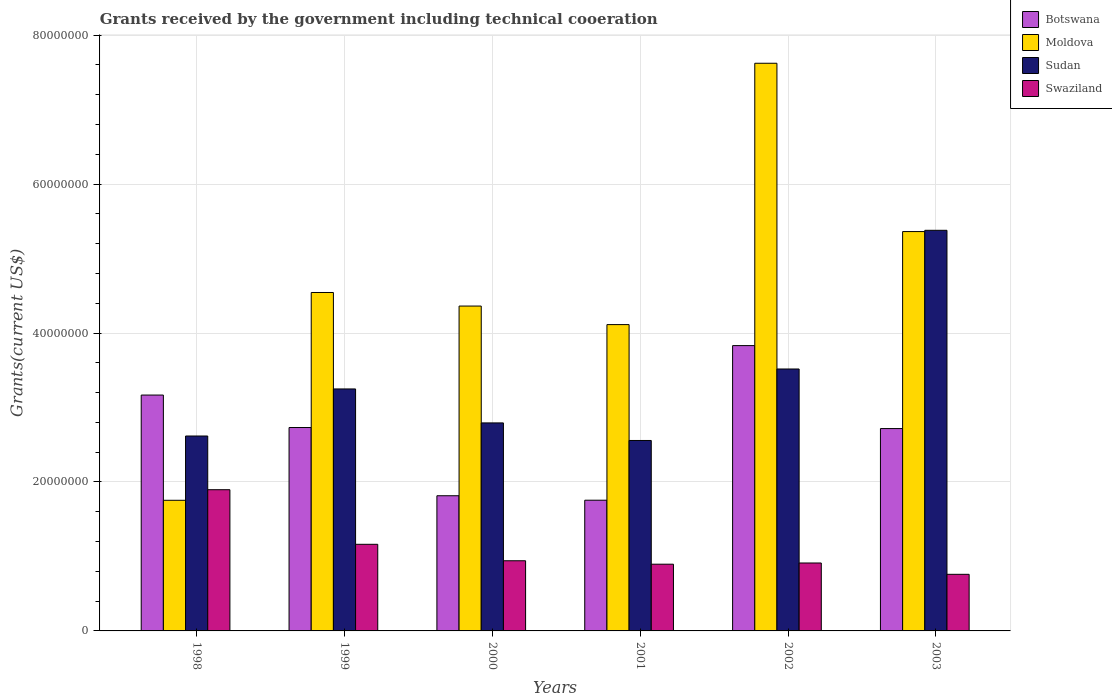How many groups of bars are there?
Offer a very short reply. 6. How many bars are there on the 5th tick from the left?
Give a very brief answer. 4. How many bars are there on the 3rd tick from the right?
Offer a very short reply. 4. What is the label of the 6th group of bars from the left?
Offer a very short reply. 2003. In how many cases, is the number of bars for a given year not equal to the number of legend labels?
Ensure brevity in your answer.  0. What is the total grants received by the government in Swaziland in 2003?
Make the answer very short. 7.60e+06. Across all years, what is the maximum total grants received by the government in Botswana?
Offer a very short reply. 3.83e+07. Across all years, what is the minimum total grants received by the government in Swaziland?
Offer a very short reply. 7.60e+06. In which year was the total grants received by the government in Botswana minimum?
Offer a very short reply. 2001. What is the total total grants received by the government in Botswana in the graph?
Your response must be concise. 1.60e+08. What is the difference between the total grants received by the government in Botswana in 1998 and that in 2000?
Keep it short and to the point. 1.35e+07. What is the difference between the total grants received by the government in Sudan in 2002 and the total grants received by the government in Moldova in 1999?
Your response must be concise. -1.03e+07. What is the average total grants received by the government in Botswana per year?
Your response must be concise. 2.67e+07. In the year 2000, what is the difference between the total grants received by the government in Moldova and total grants received by the government in Botswana?
Provide a short and direct response. 2.55e+07. In how many years, is the total grants received by the government in Moldova greater than 12000000 US$?
Provide a short and direct response. 6. What is the ratio of the total grants received by the government in Botswana in 1999 to that in 2001?
Keep it short and to the point. 1.56. Is the total grants received by the government in Botswana in 2000 less than that in 2001?
Give a very brief answer. No. What is the difference between the highest and the second highest total grants received by the government in Sudan?
Your answer should be compact. 1.86e+07. What is the difference between the highest and the lowest total grants received by the government in Sudan?
Ensure brevity in your answer.  2.82e+07. Is the sum of the total grants received by the government in Sudan in 2000 and 2003 greater than the maximum total grants received by the government in Moldova across all years?
Ensure brevity in your answer.  Yes. Is it the case that in every year, the sum of the total grants received by the government in Swaziland and total grants received by the government in Sudan is greater than the sum of total grants received by the government in Moldova and total grants received by the government in Botswana?
Provide a short and direct response. No. What does the 3rd bar from the left in 2003 represents?
Your answer should be compact. Sudan. What does the 3rd bar from the right in 2001 represents?
Give a very brief answer. Moldova. How many bars are there?
Provide a short and direct response. 24. What is the difference between two consecutive major ticks on the Y-axis?
Provide a succinct answer. 2.00e+07. Are the values on the major ticks of Y-axis written in scientific E-notation?
Provide a short and direct response. No. Does the graph contain any zero values?
Your answer should be compact. No. Does the graph contain grids?
Offer a terse response. Yes. Where does the legend appear in the graph?
Keep it short and to the point. Top right. What is the title of the graph?
Your answer should be very brief. Grants received by the government including technical cooeration. What is the label or title of the Y-axis?
Provide a short and direct response. Grants(current US$). What is the Grants(current US$) of Botswana in 1998?
Provide a short and direct response. 3.17e+07. What is the Grants(current US$) of Moldova in 1998?
Your answer should be very brief. 1.75e+07. What is the Grants(current US$) of Sudan in 1998?
Your answer should be very brief. 2.62e+07. What is the Grants(current US$) in Swaziland in 1998?
Give a very brief answer. 1.90e+07. What is the Grants(current US$) in Botswana in 1999?
Provide a succinct answer. 2.73e+07. What is the Grants(current US$) of Moldova in 1999?
Keep it short and to the point. 4.54e+07. What is the Grants(current US$) of Sudan in 1999?
Keep it short and to the point. 3.25e+07. What is the Grants(current US$) in Swaziland in 1999?
Provide a short and direct response. 1.16e+07. What is the Grants(current US$) of Botswana in 2000?
Keep it short and to the point. 1.82e+07. What is the Grants(current US$) in Moldova in 2000?
Ensure brevity in your answer.  4.36e+07. What is the Grants(current US$) of Sudan in 2000?
Keep it short and to the point. 2.79e+07. What is the Grants(current US$) of Swaziland in 2000?
Provide a succinct answer. 9.42e+06. What is the Grants(current US$) of Botswana in 2001?
Your answer should be very brief. 1.76e+07. What is the Grants(current US$) of Moldova in 2001?
Make the answer very short. 4.11e+07. What is the Grants(current US$) of Sudan in 2001?
Give a very brief answer. 2.56e+07. What is the Grants(current US$) of Swaziland in 2001?
Keep it short and to the point. 8.96e+06. What is the Grants(current US$) of Botswana in 2002?
Keep it short and to the point. 3.83e+07. What is the Grants(current US$) of Moldova in 2002?
Offer a very short reply. 7.62e+07. What is the Grants(current US$) of Sudan in 2002?
Offer a terse response. 3.52e+07. What is the Grants(current US$) in Swaziland in 2002?
Provide a short and direct response. 9.12e+06. What is the Grants(current US$) in Botswana in 2003?
Provide a short and direct response. 2.72e+07. What is the Grants(current US$) in Moldova in 2003?
Make the answer very short. 5.36e+07. What is the Grants(current US$) in Sudan in 2003?
Provide a short and direct response. 5.38e+07. What is the Grants(current US$) of Swaziland in 2003?
Provide a short and direct response. 7.60e+06. Across all years, what is the maximum Grants(current US$) of Botswana?
Provide a short and direct response. 3.83e+07. Across all years, what is the maximum Grants(current US$) in Moldova?
Ensure brevity in your answer.  7.62e+07. Across all years, what is the maximum Grants(current US$) in Sudan?
Offer a very short reply. 5.38e+07. Across all years, what is the maximum Grants(current US$) in Swaziland?
Provide a short and direct response. 1.90e+07. Across all years, what is the minimum Grants(current US$) in Botswana?
Ensure brevity in your answer.  1.76e+07. Across all years, what is the minimum Grants(current US$) in Moldova?
Your response must be concise. 1.75e+07. Across all years, what is the minimum Grants(current US$) in Sudan?
Provide a short and direct response. 2.56e+07. Across all years, what is the minimum Grants(current US$) of Swaziland?
Provide a succinct answer. 7.60e+06. What is the total Grants(current US$) in Botswana in the graph?
Offer a terse response. 1.60e+08. What is the total Grants(current US$) in Moldova in the graph?
Ensure brevity in your answer.  2.78e+08. What is the total Grants(current US$) in Sudan in the graph?
Ensure brevity in your answer.  2.01e+08. What is the total Grants(current US$) of Swaziland in the graph?
Keep it short and to the point. 6.57e+07. What is the difference between the Grants(current US$) of Botswana in 1998 and that in 1999?
Offer a terse response. 4.36e+06. What is the difference between the Grants(current US$) of Moldova in 1998 and that in 1999?
Offer a very short reply. -2.79e+07. What is the difference between the Grants(current US$) of Sudan in 1998 and that in 1999?
Your response must be concise. -6.32e+06. What is the difference between the Grants(current US$) of Swaziland in 1998 and that in 1999?
Offer a very short reply. 7.33e+06. What is the difference between the Grants(current US$) in Botswana in 1998 and that in 2000?
Provide a succinct answer. 1.35e+07. What is the difference between the Grants(current US$) of Moldova in 1998 and that in 2000?
Give a very brief answer. -2.61e+07. What is the difference between the Grants(current US$) in Sudan in 1998 and that in 2000?
Your answer should be very brief. -1.76e+06. What is the difference between the Grants(current US$) in Swaziland in 1998 and that in 2000?
Make the answer very short. 9.54e+06. What is the difference between the Grants(current US$) of Botswana in 1998 and that in 2001?
Keep it short and to the point. 1.41e+07. What is the difference between the Grants(current US$) in Moldova in 1998 and that in 2001?
Ensure brevity in your answer.  -2.36e+07. What is the difference between the Grants(current US$) of Sudan in 1998 and that in 2001?
Give a very brief answer. 6.00e+05. What is the difference between the Grants(current US$) in Swaziland in 1998 and that in 2001?
Your response must be concise. 1.00e+07. What is the difference between the Grants(current US$) of Botswana in 1998 and that in 2002?
Your response must be concise. -6.64e+06. What is the difference between the Grants(current US$) in Moldova in 1998 and that in 2002?
Offer a terse response. -5.87e+07. What is the difference between the Grants(current US$) in Sudan in 1998 and that in 2002?
Provide a succinct answer. -9.00e+06. What is the difference between the Grants(current US$) in Swaziland in 1998 and that in 2002?
Keep it short and to the point. 9.84e+06. What is the difference between the Grants(current US$) in Botswana in 1998 and that in 2003?
Keep it short and to the point. 4.50e+06. What is the difference between the Grants(current US$) of Moldova in 1998 and that in 2003?
Your answer should be very brief. -3.61e+07. What is the difference between the Grants(current US$) of Sudan in 1998 and that in 2003?
Offer a very short reply. -2.76e+07. What is the difference between the Grants(current US$) in Swaziland in 1998 and that in 2003?
Give a very brief answer. 1.14e+07. What is the difference between the Grants(current US$) in Botswana in 1999 and that in 2000?
Offer a very short reply. 9.16e+06. What is the difference between the Grants(current US$) of Moldova in 1999 and that in 2000?
Your response must be concise. 1.82e+06. What is the difference between the Grants(current US$) of Sudan in 1999 and that in 2000?
Your answer should be very brief. 4.56e+06. What is the difference between the Grants(current US$) of Swaziland in 1999 and that in 2000?
Ensure brevity in your answer.  2.21e+06. What is the difference between the Grants(current US$) in Botswana in 1999 and that in 2001?
Your response must be concise. 9.76e+06. What is the difference between the Grants(current US$) in Moldova in 1999 and that in 2001?
Offer a terse response. 4.31e+06. What is the difference between the Grants(current US$) of Sudan in 1999 and that in 2001?
Your answer should be very brief. 6.92e+06. What is the difference between the Grants(current US$) in Swaziland in 1999 and that in 2001?
Give a very brief answer. 2.67e+06. What is the difference between the Grants(current US$) of Botswana in 1999 and that in 2002?
Offer a very short reply. -1.10e+07. What is the difference between the Grants(current US$) in Moldova in 1999 and that in 2002?
Ensure brevity in your answer.  -3.08e+07. What is the difference between the Grants(current US$) of Sudan in 1999 and that in 2002?
Ensure brevity in your answer.  -2.68e+06. What is the difference between the Grants(current US$) of Swaziland in 1999 and that in 2002?
Ensure brevity in your answer.  2.51e+06. What is the difference between the Grants(current US$) of Moldova in 1999 and that in 2003?
Keep it short and to the point. -8.18e+06. What is the difference between the Grants(current US$) in Sudan in 1999 and that in 2003?
Provide a succinct answer. -2.13e+07. What is the difference between the Grants(current US$) of Swaziland in 1999 and that in 2003?
Offer a very short reply. 4.03e+06. What is the difference between the Grants(current US$) of Moldova in 2000 and that in 2001?
Offer a very short reply. 2.49e+06. What is the difference between the Grants(current US$) of Sudan in 2000 and that in 2001?
Offer a very short reply. 2.36e+06. What is the difference between the Grants(current US$) of Swaziland in 2000 and that in 2001?
Offer a terse response. 4.60e+05. What is the difference between the Grants(current US$) in Botswana in 2000 and that in 2002?
Make the answer very short. -2.02e+07. What is the difference between the Grants(current US$) of Moldova in 2000 and that in 2002?
Offer a terse response. -3.26e+07. What is the difference between the Grants(current US$) in Sudan in 2000 and that in 2002?
Keep it short and to the point. -7.24e+06. What is the difference between the Grants(current US$) of Botswana in 2000 and that in 2003?
Make the answer very short. -9.02e+06. What is the difference between the Grants(current US$) of Moldova in 2000 and that in 2003?
Give a very brief answer. -1.00e+07. What is the difference between the Grants(current US$) of Sudan in 2000 and that in 2003?
Your answer should be very brief. -2.59e+07. What is the difference between the Grants(current US$) of Swaziland in 2000 and that in 2003?
Keep it short and to the point. 1.82e+06. What is the difference between the Grants(current US$) in Botswana in 2001 and that in 2002?
Keep it short and to the point. -2.08e+07. What is the difference between the Grants(current US$) in Moldova in 2001 and that in 2002?
Your answer should be compact. -3.51e+07. What is the difference between the Grants(current US$) in Sudan in 2001 and that in 2002?
Make the answer very short. -9.60e+06. What is the difference between the Grants(current US$) of Botswana in 2001 and that in 2003?
Ensure brevity in your answer.  -9.62e+06. What is the difference between the Grants(current US$) of Moldova in 2001 and that in 2003?
Give a very brief answer. -1.25e+07. What is the difference between the Grants(current US$) of Sudan in 2001 and that in 2003?
Your answer should be compact. -2.82e+07. What is the difference between the Grants(current US$) in Swaziland in 2001 and that in 2003?
Your answer should be very brief. 1.36e+06. What is the difference between the Grants(current US$) in Botswana in 2002 and that in 2003?
Offer a terse response. 1.11e+07. What is the difference between the Grants(current US$) in Moldova in 2002 and that in 2003?
Your answer should be very brief. 2.26e+07. What is the difference between the Grants(current US$) of Sudan in 2002 and that in 2003?
Your answer should be compact. -1.86e+07. What is the difference between the Grants(current US$) in Swaziland in 2002 and that in 2003?
Provide a succinct answer. 1.52e+06. What is the difference between the Grants(current US$) of Botswana in 1998 and the Grants(current US$) of Moldova in 1999?
Your answer should be compact. -1.38e+07. What is the difference between the Grants(current US$) of Botswana in 1998 and the Grants(current US$) of Sudan in 1999?
Give a very brief answer. -8.20e+05. What is the difference between the Grants(current US$) of Botswana in 1998 and the Grants(current US$) of Swaziland in 1999?
Your answer should be compact. 2.00e+07. What is the difference between the Grants(current US$) in Moldova in 1998 and the Grants(current US$) in Sudan in 1999?
Your answer should be compact. -1.50e+07. What is the difference between the Grants(current US$) in Moldova in 1998 and the Grants(current US$) in Swaziland in 1999?
Offer a very short reply. 5.91e+06. What is the difference between the Grants(current US$) of Sudan in 1998 and the Grants(current US$) of Swaziland in 1999?
Give a very brief answer. 1.45e+07. What is the difference between the Grants(current US$) in Botswana in 1998 and the Grants(current US$) in Moldova in 2000?
Your response must be concise. -1.20e+07. What is the difference between the Grants(current US$) of Botswana in 1998 and the Grants(current US$) of Sudan in 2000?
Your response must be concise. 3.74e+06. What is the difference between the Grants(current US$) of Botswana in 1998 and the Grants(current US$) of Swaziland in 2000?
Offer a very short reply. 2.22e+07. What is the difference between the Grants(current US$) of Moldova in 1998 and the Grants(current US$) of Sudan in 2000?
Keep it short and to the point. -1.04e+07. What is the difference between the Grants(current US$) of Moldova in 1998 and the Grants(current US$) of Swaziland in 2000?
Offer a terse response. 8.12e+06. What is the difference between the Grants(current US$) in Sudan in 1998 and the Grants(current US$) in Swaziland in 2000?
Your answer should be compact. 1.68e+07. What is the difference between the Grants(current US$) in Botswana in 1998 and the Grants(current US$) in Moldova in 2001?
Ensure brevity in your answer.  -9.46e+06. What is the difference between the Grants(current US$) in Botswana in 1998 and the Grants(current US$) in Sudan in 2001?
Your response must be concise. 6.10e+06. What is the difference between the Grants(current US$) of Botswana in 1998 and the Grants(current US$) of Swaziland in 2001?
Ensure brevity in your answer.  2.27e+07. What is the difference between the Grants(current US$) of Moldova in 1998 and the Grants(current US$) of Sudan in 2001?
Make the answer very short. -8.03e+06. What is the difference between the Grants(current US$) of Moldova in 1998 and the Grants(current US$) of Swaziland in 2001?
Offer a terse response. 8.58e+06. What is the difference between the Grants(current US$) in Sudan in 1998 and the Grants(current US$) in Swaziland in 2001?
Your answer should be very brief. 1.72e+07. What is the difference between the Grants(current US$) in Botswana in 1998 and the Grants(current US$) in Moldova in 2002?
Your response must be concise. -4.46e+07. What is the difference between the Grants(current US$) of Botswana in 1998 and the Grants(current US$) of Sudan in 2002?
Ensure brevity in your answer.  -3.50e+06. What is the difference between the Grants(current US$) in Botswana in 1998 and the Grants(current US$) in Swaziland in 2002?
Offer a terse response. 2.26e+07. What is the difference between the Grants(current US$) of Moldova in 1998 and the Grants(current US$) of Sudan in 2002?
Your answer should be very brief. -1.76e+07. What is the difference between the Grants(current US$) in Moldova in 1998 and the Grants(current US$) in Swaziland in 2002?
Give a very brief answer. 8.42e+06. What is the difference between the Grants(current US$) in Sudan in 1998 and the Grants(current US$) in Swaziland in 2002?
Offer a terse response. 1.70e+07. What is the difference between the Grants(current US$) of Botswana in 1998 and the Grants(current US$) of Moldova in 2003?
Make the answer very short. -2.20e+07. What is the difference between the Grants(current US$) in Botswana in 1998 and the Grants(current US$) in Sudan in 2003?
Provide a short and direct response. -2.21e+07. What is the difference between the Grants(current US$) in Botswana in 1998 and the Grants(current US$) in Swaziland in 2003?
Keep it short and to the point. 2.41e+07. What is the difference between the Grants(current US$) of Moldova in 1998 and the Grants(current US$) of Sudan in 2003?
Your answer should be very brief. -3.62e+07. What is the difference between the Grants(current US$) in Moldova in 1998 and the Grants(current US$) in Swaziland in 2003?
Keep it short and to the point. 9.94e+06. What is the difference between the Grants(current US$) in Sudan in 1998 and the Grants(current US$) in Swaziland in 2003?
Provide a short and direct response. 1.86e+07. What is the difference between the Grants(current US$) of Botswana in 1999 and the Grants(current US$) of Moldova in 2000?
Ensure brevity in your answer.  -1.63e+07. What is the difference between the Grants(current US$) in Botswana in 1999 and the Grants(current US$) in Sudan in 2000?
Provide a short and direct response. -6.20e+05. What is the difference between the Grants(current US$) in Botswana in 1999 and the Grants(current US$) in Swaziland in 2000?
Keep it short and to the point. 1.79e+07. What is the difference between the Grants(current US$) of Moldova in 1999 and the Grants(current US$) of Sudan in 2000?
Your answer should be very brief. 1.75e+07. What is the difference between the Grants(current US$) in Moldova in 1999 and the Grants(current US$) in Swaziland in 2000?
Your answer should be compact. 3.60e+07. What is the difference between the Grants(current US$) of Sudan in 1999 and the Grants(current US$) of Swaziland in 2000?
Your answer should be very brief. 2.31e+07. What is the difference between the Grants(current US$) in Botswana in 1999 and the Grants(current US$) in Moldova in 2001?
Make the answer very short. -1.38e+07. What is the difference between the Grants(current US$) in Botswana in 1999 and the Grants(current US$) in Sudan in 2001?
Provide a short and direct response. 1.74e+06. What is the difference between the Grants(current US$) in Botswana in 1999 and the Grants(current US$) in Swaziland in 2001?
Your response must be concise. 1.84e+07. What is the difference between the Grants(current US$) in Moldova in 1999 and the Grants(current US$) in Sudan in 2001?
Offer a terse response. 1.99e+07. What is the difference between the Grants(current US$) in Moldova in 1999 and the Grants(current US$) in Swaziland in 2001?
Offer a terse response. 3.65e+07. What is the difference between the Grants(current US$) of Sudan in 1999 and the Grants(current US$) of Swaziland in 2001?
Provide a succinct answer. 2.35e+07. What is the difference between the Grants(current US$) of Botswana in 1999 and the Grants(current US$) of Moldova in 2002?
Give a very brief answer. -4.89e+07. What is the difference between the Grants(current US$) in Botswana in 1999 and the Grants(current US$) in Sudan in 2002?
Ensure brevity in your answer.  -7.86e+06. What is the difference between the Grants(current US$) of Botswana in 1999 and the Grants(current US$) of Swaziland in 2002?
Offer a terse response. 1.82e+07. What is the difference between the Grants(current US$) in Moldova in 1999 and the Grants(current US$) in Sudan in 2002?
Offer a terse response. 1.03e+07. What is the difference between the Grants(current US$) of Moldova in 1999 and the Grants(current US$) of Swaziland in 2002?
Offer a terse response. 3.63e+07. What is the difference between the Grants(current US$) of Sudan in 1999 and the Grants(current US$) of Swaziland in 2002?
Offer a terse response. 2.34e+07. What is the difference between the Grants(current US$) in Botswana in 1999 and the Grants(current US$) in Moldova in 2003?
Your answer should be compact. -2.63e+07. What is the difference between the Grants(current US$) in Botswana in 1999 and the Grants(current US$) in Sudan in 2003?
Provide a succinct answer. -2.65e+07. What is the difference between the Grants(current US$) in Botswana in 1999 and the Grants(current US$) in Swaziland in 2003?
Give a very brief answer. 1.97e+07. What is the difference between the Grants(current US$) in Moldova in 1999 and the Grants(current US$) in Sudan in 2003?
Offer a terse response. -8.35e+06. What is the difference between the Grants(current US$) of Moldova in 1999 and the Grants(current US$) of Swaziland in 2003?
Your answer should be very brief. 3.78e+07. What is the difference between the Grants(current US$) in Sudan in 1999 and the Grants(current US$) in Swaziland in 2003?
Your answer should be very brief. 2.49e+07. What is the difference between the Grants(current US$) in Botswana in 2000 and the Grants(current US$) in Moldova in 2001?
Offer a very short reply. -2.30e+07. What is the difference between the Grants(current US$) of Botswana in 2000 and the Grants(current US$) of Sudan in 2001?
Your response must be concise. -7.42e+06. What is the difference between the Grants(current US$) of Botswana in 2000 and the Grants(current US$) of Swaziland in 2001?
Give a very brief answer. 9.19e+06. What is the difference between the Grants(current US$) of Moldova in 2000 and the Grants(current US$) of Sudan in 2001?
Keep it short and to the point. 1.80e+07. What is the difference between the Grants(current US$) of Moldova in 2000 and the Grants(current US$) of Swaziland in 2001?
Give a very brief answer. 3.47e+07. What is the difference between the Grants(current US$) in Sudan in 2000 and the Grants(current US$) in Swaziland in 2001?
Provide a succinct answer. 1.90e+07. What is the difference between the Grants(current US$) in Botswana in 2000 and the Grants(current US$) in Moldova in 2002?
Your answer should be very brief. -5.81e+07. What is the difference between the Grants(current US$) of Botswana in 2000 and the Grants(current US$) of Sudan in 2002?
Ensure brevity in your answer.  -1.70e+07. What is the difference between the Grants(current US$) in Botswana in 2000 and the Grants(current US$) in Swaziland in 2002?
Ensure brevity in your answer.  9.03e+06. What is the difference between the Grants(current US$) in Moldova in 2000 and the Grants(current US$) in Sudan in 2002?
Provide a short and direct response. 8.45e+06. What is the difference between the Grants(current US$) in Moldova in 2000 and the Grants(current US$) in Swaziland in 2002?
Give a very brief answer. 3.45e+07. What is the difference between the Grants(current US$) in Sudan in 2000 and the Grants(current US$) in Swaziland in 2002?
Your response must be concise. 1.88e+07. What is the difference between the Grants(current US$) in Botswana in 2000 and the Grants(current US$) in Moldova in 2003?
Give a very brief answer. -3.55e+07. What is the difference between the Grants(current US$) in Botswana in 2000 and the Grants(current US$) in Sudan in 2003?
Keep it short and to the point. -3.56e+07. What is the difference between the Grants(current US$) in Botswana in 2000 and the Grants(current US$) in Swaziland in 2003?
Your answer should be compact. 1.06e+07. What is the difference between the Grants(current US$) of Moldova in 2000 and the Grants(current US$) of Sudan in 2003?
Offer a very short reply. -1.02e+07. What is the difference between the Grants(current US$) of Moldova in 2000 and the Grants(current US$) of Swaziland in 2003?
Ensure brevity in your answer.  3.60e+07. What is the difference between the Grants(current US$) in Sudan in 2000 and the Grants(current US$) in Swaziland in 2003?
Offer a very short reply. 2.03e+07. What is the difference between the Grants(current US$) in Botswana in 2001 and the Grants(current US$) in Moldova in 2002?
Keep it short and to the point. -5.87e+07. What is the difference between the Grants(current US$) in Botswana in 2001 and the Grants(current US$) in Sudan in 2002?
Offer a very short reply. -1.76e+07. What is the difference between the Grants(current US$) of Botswana in 2001 and the Grants(current US$) of Swaziland in 2002?
Provide a short and direct response. 8.43e+06. What is the difference between the Grants(current US$) in Moldova in 2001 and the Grants(current US$) in Sudan in 2002?
Offer a terse response. 5.96e+06. What is the difference between the Grants(current US$) in Moldova in 2001 and the Grants(current US$) in Swaziland in 2002?
Provide a succinct answer. 3.20e+07. What is the difference between the Grants(current US$) in Sudan in 2001 and the Grants(current US$) in Swaziland in 2002?
Your answer should be compact. 1.64e+07. What is the difference between the Grants(current US$) of Botswana in 2001 and the Grants(current US$) of Moldova in 2003?
Make the answer very short. -3.61e+07. What is the difference between the Grants(current US$) of Botswana in 2001 and the Grants(current US$) of Sudan in 2003?
Make the answer very short. -3.62e+07. What is the difference between the Grants(current US$) of Botswana in 2001 and the Grants(current US$) of Swaziland in 2003?
Your answer should be compact. 9.95e+06. What is the difference between the Grants(current US$) in Moldova in 2001 and the Grants(current US$) in Sudan in 2003?
Keep it short and to the point. -1.27e+07. What is the difference between the Grants(current US$) of Moldova in 2001 and the Grants(current US$) of Swaziland in 2003?
Provide a succinct answer. 3.35e+07. What is the difference between the Grants(current US$) in Sudan in 2001 and the Grants(current US$) in Swaziland in 2003?
Ensure brevity in your answer.  1.80e+07. What is the difference between the Grants(current US$) of Botswana in 2002 and the Grants(current US$) of Moldova in 2003?
Provide a short and direct response. -1.53e+07. What is the difference between the Grants(current US$) in Botswana in 2002 and the Grants(current US$) in Sudan in 2003?
Ensure brevity in your answer.  -1.55e+07. What is the difference between the Grants(current US$) of Botswana in 2002 and the Grants(current US$) of Swaziland in 2003?
Make the answer very short. 3.07e+07. What is the difference between the Grants(current US$) in Moldova in 2002 and the Grants(current US$) in Sudan in 2003?
Provide a succinct answer. 2.24e+07. What is the difference between the Grants(current US$) in Moldova in 2002 and the Grants(current US$) in Swaziland in 2003?
Provide a short and direct response. 6.86e+07. What is the difference between the Grants(current US$) of Sudan in 2002 and the Grants(current US$) of Swaziland in 2003?
Your answer should be very brief. 2.76e+07. What is the average Grants(current US$) in Botswana per year?
Keep it short and to the point. 2.67e+07. What is the average Grants(current US$) of Moldova per year?
Provide a succinct answer. 4.63e+07. What is the average Grants(current US$) in Sudan per year?
Your response must be concise. 3.35e+07. What is the average Grants(current US$) of Swaziland per year?
Offer a terse response. 1.09e+07. In the year 1998, what is the difference between the Grants(current US$) of Botswana and Grants(current US$) of Moldova?
Your response must be concise. 1.41e+07. In the year 1998, what is the difference between the Grants(current US$) in Botswana and Grants(current US$) in Sudan?
Give a very brief answer. 5.50e+06. In the year 1998, what is the difference between the Grants(current US$) in Botswana and Grants(current US$) in Swaziland?
Make the answer very short. 1.27e+07. In the year 1998, what is the difference between the Grants(current US$) in Moldova and Grants(current US$) in Sudan?
Offer a terse response. -8.63e+06. In the year 1998, what is the difference between the Grants(current US$) in Moldova and Grants(current US$) in Swaziland?
Your response must be concise. -1.42e+06. In the year 1998, what is the difference between the Grants(current US$) in Sudan and Grants(current US$) in Swaziland?
Keep it short and to the point. 7.21e+06. In the year 1999, what is the difference between the Grants(current US$) in Botswana and Grants(current US$) in Moldova?
Give a very brief answer. -1.81e+07. In the year 1999, what is the difference between the Grants(current US$) of Botswana and Grants(current US$) of Sudan?
Provide a short and direct response. -5.18e+06. In the year 1999, what is the difference between the Grants(current US$) in Botswana and Grants(current US$) in Swaziland?
Your answer should be compact. 1.57e+07. In the year 1999, what is the difference between the Grants(current US$) of Moldova and Grants(current US$) of Sudan?
Your answer should be very brief. 1.30e+07. In the year 1999, what is the difference between the Grants(current US$) of Moldova and Grants(current US$) of Swaziland?
Your response must be concise. 3.38e+07. In the year 1999, what is the difference between the Grants(current US$) in Sudan and Grants(current US$) in Swaziland?
Give a very brief answer. 2.09e+07. In the year 2000, what is the difference between the Grants(current US$) of Botswana and Grants(current US$) of Moldova?
Offer a very short reply. -2.55e+07. In the year 2000, what is the difference between the Grants(current US$) of Botswana and Grants(current US$) of Sudan?
Make the answer very short. -9.78e+06. In the year 2000, what is the difference between the Grants(current US$) of Botswana and Grants(current US$) of Swaziland?
Offer a very short reply. 8.73e+06. In the year 2000, what is the difference between the Grants(current US$) in Moldova and Grants(current US$) in Sudan?
Your answer should be compact. 1.57e+07. In the year 2000, what is the difference between the Grants(current US$) in Moldova and Grants(current US$) in Swaziland?
Make the answer very short. 3.42e+07. In the year 2000, what is the difference between the Grants(current US$) in Sudan and Grants(current US$) in Swaziland?
Provide a short and direct response. 1.85e+07. In the year 2001, what is the difference between the Grants(current US$) in Botswana and Grants(current US$) in Moldova?
Offer a terse response. -2.36e+07. In the year 2001, what is the difference between the Grants(current US$) in Botswana and Grants(current US$) in Sudan?
Ensure brevity in your answer.  -8.02e+06. In the year 2001, what is the difference between the Grants(current US$) in Botswana and Grants(current US$) in Swaziland?
Ensure brevity in your answer.  8.59e+06. In the year 2001, what is the difference between the Grants(current US$) in Moldova and Grants(current US$) in Sudan?
Your answer should be compact. 1.56e+07. In the year 2001, what is the difference between the Grants(current US$) of Moldova and Grants(current US$) of Swaziland?
Offer a terse response. 3.22e+07. In the year 2001, what is the difference between the Grants(current US$) of Sudan and Grants(current US$) of Swaziland?
Give a very brief answer. 1.66e+07. In the year 2002, what is the difference between the Grants(current US$) in Botswana and Grants(current US$) in Moldova?
Provide a short and direct response. -3.79e+07. In the year 2002, what is the difference between the Grants(current US$) of Botswana and Grants(current US$) of Sudan?
Make the answer very short. 3.14e+06. In the year 2002, what is the difference between the Grants(current US$) in Botswana and Grants(current US$) in Swaziland?
Make the answer very short. 2.92e+07. In the year 2002, what is the difference between the Grants(current US$) in Moldova and Grants(current US$) in Sudan?
Your response must be concise. 4.10e+07. In the year 2002, what is the difference between the Grants(current US$) of Moldova and Grants(current US$) of Swaziland?
Your answer should be compact. 6.71e+07. In the year 2002, what is the difference between the Grants(current US$) of Sudan and Grants(current US$) of Swaziland?
Offer a terse response. 2.60e+07. In the year 2003, what is the difference between the Grants(current US$) in Botswana and Grants(current US$) in Moldova?
Your answer should be very brief. -2.64e+07. In the year 2003, what is the difference between the Grants(current US$) in Botswana and Grants(current US$) in Sudan?
Provide a succinct answer. -2.66e+07. In the year 2003, what is the difference between the Grants(current US$) of Botswana and Grants(current US$) of Swaziland?
Ensure brevity in your answer.  1.96e+07. In the year 2003, what is the difference between the Grants(current US$) of Moldova and Grants(current US$) of Sudan?
Your answer should be compact. -1.70e+05. In the year 2003, what is the difference between the Grants(current US$) in Moldova and Grants(current US$) in Swaziland?
Ensure brevity in your answer.  4.60e+07. In the year 2003, what is the difference between the Grants(current US$) in Sudan and Grants(current US$) in Swaziland?
Make the answer very short. 4.62e+07. What is the ratio of the Grants(current US$) of Botswana in 1998 to that in 1999?
Ensure brevity in your answer.  1.16. What is the ratio of the Grants(current US$) of Moldova in 1998 to that in 1999?
Give a very brief answer. 0.39. What is the ratio of the Grants(current US$) in Sudan in 1998 to that in 1999?
Your response must be concise. 0.81. What is the ratio of the Grants(current US$) in Swaziland in 1998 to that in 1999?
Make the answer very short. 1.63. What is the ratio of the Grants(current US$) in Botswana in 1998 to that in 2000?
Your answer should be compact. 1.74. What is the ratio of the Grants(current US$) in Moldova in 1998 to that in 2000?
Provide a succinct answer. 0.4. What is the ratio of the Grants(current US$) in Sudan in 1998 to that in 2000?
Keep it short and to the point. 0.94. What is the ratio of the Grants(current US$) in Swaziland in 1998 to that in 2000?
Offer a terse response. 2.01. What is the ratio of the Grants(current US$) of Botswana in 1998 to that in 2001?
Provide a succinct answer. 1.8. What is the ratio of the Grants(current US$) of Moldova in 1998 to that in 2001?
Offer a terse response. 0.43. What is the ratio of the Grants(current US$) in Sudan in 1998 to that in 2001?
Your answer should be very brief. 1.02. What is the ratio of the Grants(current US$) in Swaziland in 1998 to that in 2001?
Your response must be concise. 2.12. What is the ratio of the Grants(current US$) in Botswana in 1998 to that in 2002?
Your answer should be compact. 0.83. What is the ratio of the Grants(current US$) of Moldova in 1998 to that in 2002?
Provide a short and direct response. 0.23. What is the ratio of the Grants(current US$) of Sudan in 1998 to that in 2002?
Your answer should be compact. 0.74. What is the ratio of the Grants(current US$) of Swaziland in 1998 to that in 2002?
Make the answer very short. 2.08. What is the ratio of the Grants(current US$) of Botswana in 1998 to that in 2003?
Your answer should be very brief. 1.17. What is the ratio of the Grants(current US$) in Moldova in 1998 to that in 2003?
Keep it short and to the point. 0.33. What is the ratio of the Grants(current US$) of Sudan in 1998 to that in 2003?
Provide a short and direct response. 0.49. What is the ratio of the Grants(current US$) of Swaziland in 1998 to that in 2003?
Your response must be concise. 2.49. What is the ratio of the Grants(current US$) in Botswana in 1999 to that in 2000?
Ensure brevity in your answer.  1.5. What is the ratio of the Grants(current US$) of Moldova in 1999 to that in 2000?
Your answer should be compact. 1.04. What is the ratio of the Grants(current US$) in Sudan in 1999 to that in 2000?
Ensure brevity in your answer.  1.16. What is the ratio of the Grants(current US$) in Swaziland in 1999 to that in 2000?
Give a very brief answer. 1.23. What is the ratio of the Grants(current US$) in Botswana in 1999 to that in 2001?
Your answer should be very brief. 1.56. What is the ratio of the Grants(current US$) of Moldova in 1999 to that in 2001?
Your response must be concise. 1.1. What is the ratio of the Grants(current US$) in Sudan in 1999 to that in 2001?
Make the answer very short. 1.27. What is the ratio of the Grants(current US$) of Swaziland in 1999 to that in 2001?
Keep it short and to the point. 1.3. What is the ratio of the Grants(current US$) in Botswana in 1999 to that in 2002?
Make the answer very short. 0.71. What is the ratio of the Grants(current US$) in Moldova in 1999 to that in 2002?
Offer a terse response. 0.6. What is the ratio of the Grants(current US$) of Sudan in 1999 to that in 2002?
Offer a very short reply. 0.92. What is the ratio of the Grants(current US$) of Swaziland in 1999 to that in 2002?
Your answer should be compact. 1.28. What is the ratio of the Grants(current US$) in Botswana in 1999 to that in 2003?
Offer a very short reply. 1.01. What is the ratio of the Grants(current US$) of Moldova in 1999 to that in 2003?
Provide a short and direct response. 0.85. What is the ratio of the Grants(current US$) of Sudan in 1999 to that in 2003?
Give a very brief answer. 0.6. What is the ratio of the Grants(current US$) of Swaziland in 1999 to that in 2003?
Provide a succinct answer. 1.53. What is the ratio of the Grants(current US$) of Botswana in 2000 to that in 2001?
Ensure brevity in your answer.  1.03. What is the ratio of the Grants(current US$) of Moldova in 2000 to that in 2001?
Provide a short and direct response. 1.06. What is the ratio of the Grants(current US$) of Sudan in 2000 to that in 2001?
Ensure brevity in your answer.  1.09. What is the ratio of the Grants(current US$) in Swaziland in 2000 to that in 2001?
Offer a terse response. 1.05. What is the ratio of the Grants(current US$) in Botswana in 2000 to that in 2002?
Your answer should be very brief. 0.47. What is the ratio of the Grants(current US$) of Moldova in 2000 to that in 2002?
Offer a very short reply. 0.57. What is the ratio of the Grants(current US$) in Sudan in 2000 to that in 2002?
Your response must be concise. 0.79. What is the ratio of the Grants(current US$) of Swaziland in 2000 to that in 2002?
Provide a succinct answer. 1.03. What is the ratio of the Grants(current US$) of Botswana in 2000 to that in 2003?
Keep it short and to the point. 0.67. What is the ratio of the Grants(current US$) in Moldova in 2000 to that in 2003?
Ensure brevity in your answer.  0.81. What is the ratio of the Grants(current US$) in Sudan in 2000 to that in 2003?
Provide a short and direct response. 0.52. What is the ratio of the Grants(current US$) in Swaziland in 2000 to that in 2003?
Your response must be concise. 1.24. What is the ratio of the Grants(current US$) in Botswana in 2001 to that in 2002?
Your answer should be very brief. 0.46. What is the ratio of the Grants(current US$) in Moldova in 2001 to that in 2002?
Offer a very short reply. 0.54. What is the ratio of the Grants(current US$) in Sudan in 2001 to that in 2002?
Keep it short and to the point. 0.73. What is the ratio of the Grants(current US$) of Swaziland in 2001 to that in 2002?
Your answer should be very brief. 0.98. What is the ratio of the Grants(current US$) of Botswana in 2001 to that in 2003?
Provide a succinct answer. 0.65. What is the ratio of the Grants(current US$) in Moldova in 2001 to that in 2003?
Offer a terse response. 0.77. What is the ratio of the Grants(current US$) of Sudan in 2001 to that in 2003?
Ensure brevity in your answer.  0.48. What is the ratio of the Grants(current US$) of Swaziland in 2001 to that in 2003?
Your answer should be compact. 1.18. What is the ratio of the Grants(current US$) in Botswana in 2002 to that in 2003?
Your answer should be compact. 1.41. What is the ratio of the Grants(current US$) in Moldova in 2002 to that in 2003?
Keep it short and to the point. 1.42. What is the ratio of the Grants(current US$) of Sudan in 2002 to that in 2003?
Your answer should be very brief. 0.65. What is the difference between the highest and the second highest Grants(current US$) in Botswana?
Ensure brevity in your answer.  6.64e+06. What is the difference between the highest and the second highest Grants(current US$) in Moldova?
Your answer should be very brief. 2.26e+07. What is the difference between the highest and the second highest Grants(current US$) of Sudan?
Ensure brevity in your answer.  1.86e+07. What is the difference between the highest and the second highest Grants(current US$) of Swaziland?
Your answer should be compact. 7.33e+06. What is the difference between the highest and the lowest Grants(current US$) of Botswana?
Ensure brevity in your answer.  2.08e+07. What is the difference between the highest and the lowest Grants(current US$) of Moldova?
Provide a succinct answer. 5.87e+07. What is the difference between the highest and the lowest Grants(current US$) in Sudan?
Offer a very short reply. 2.82e+07. What is the difference between the highest and the lowest Grants(current US$) of Swaziland?
Offer a terse response. 1.14e+07. 